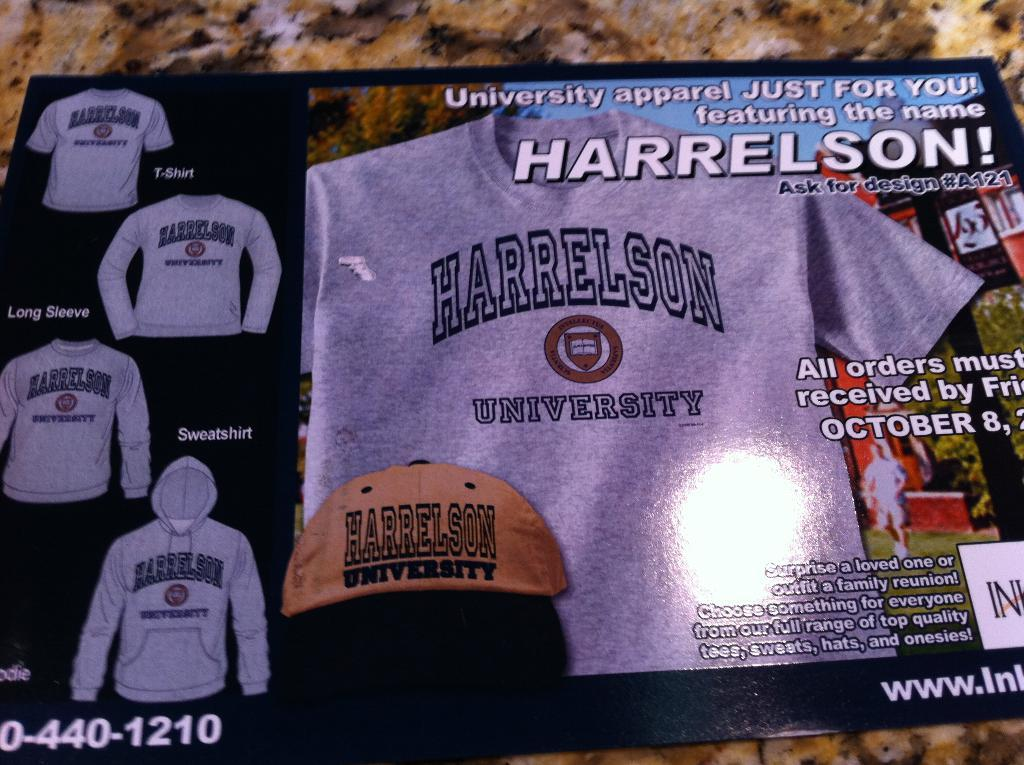Provide a one-sentence caption for the provided image. An advertisement for Harrelson University apparel including shirts, sweatshirts and hats. 